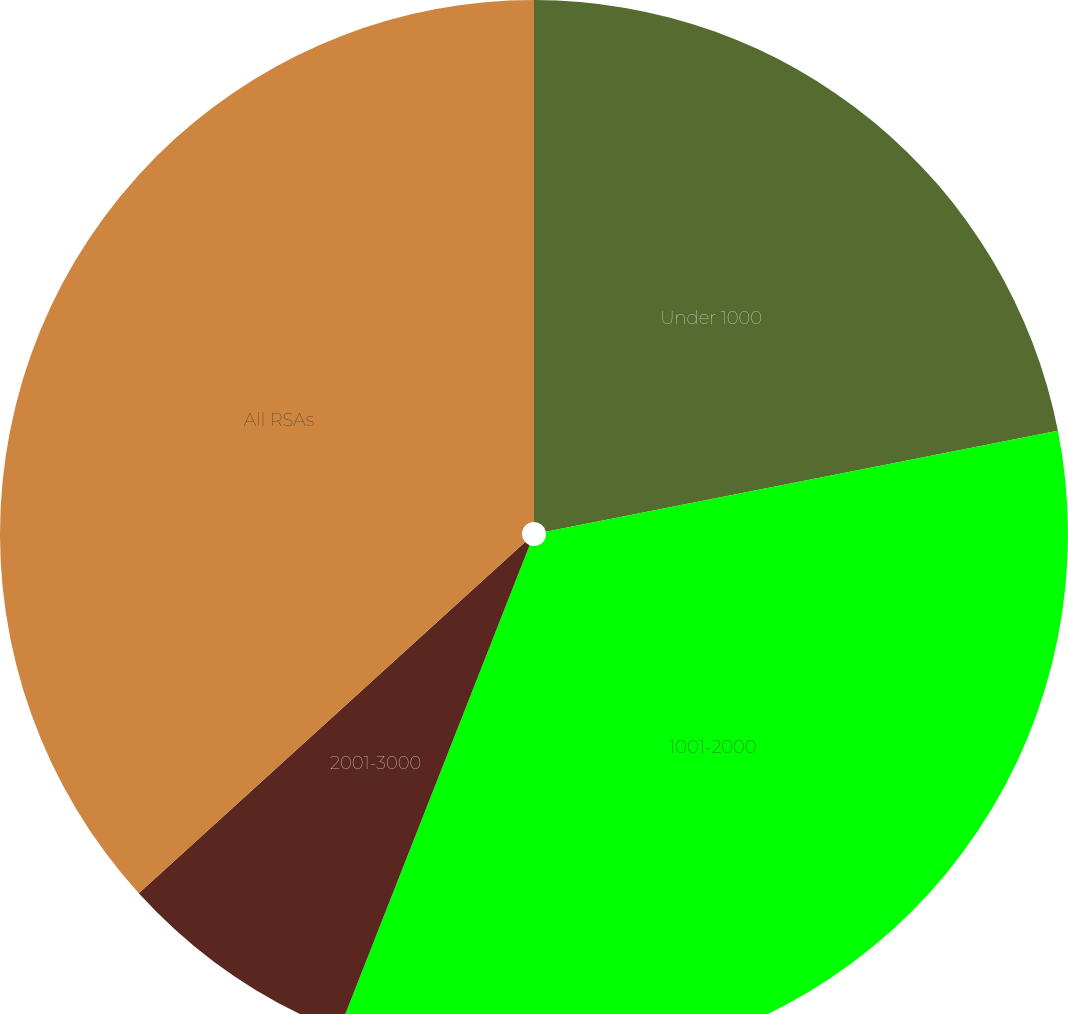<chart> <loc_0><loc_0><loc_500><loc_500><pie_chart><fcel>Under 1000<fcel>1001-2000<fcel>2001-3000<fcel>All RSAs<nl><fcel>21.9%<fcel>34.06%<fcel>7.3%<fcel>36.74%<nl></chart> 